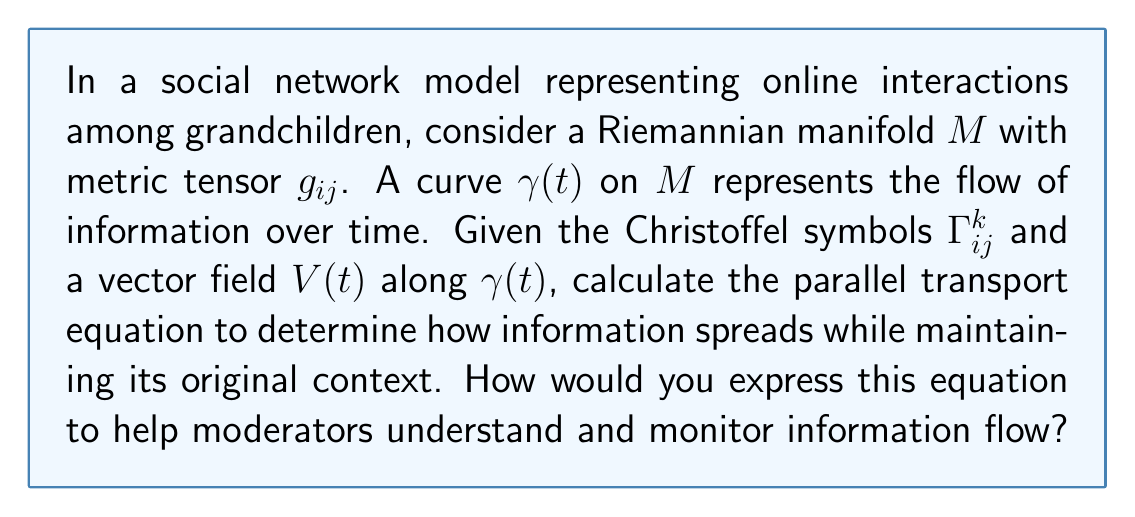What is the answer to this math problem? To understand how information spreads in a social network while maintaining its context, we can use parallel transport along a curve on a Riemannian manifold. This process helps moderators track and protect grandchildren from potential online risks. Let's break down the solution:

1. Recall the parallel transport equation:
   $$\frac{DV^i}{dt} = \frac{dV^i}{dt} + \Gamma^i_{jk} V^j \frac{d\gamma^k}{dt} = 0$$

2. Here, $V^i$ are the components of the vector field $V(t)$, representing the information being transported.

3. $\frac{d\gamma^k}{dt}$ represents the tangent vector to the curve $\gamma(t)$, indicating the direction of information flow.

4. $\Gamma^i_{jk}$ are the Christoffel symbols, which encode how the manifold (social network) is curved.

5. The equation states that the covariant derivative of $V$ along $\gamma$ is zero, meaning the vector is transported parallel to itself.

6. Expanding the equation:
   $$\frac{dV^i}{dt} = -\Gamma^i_{jk} V^j \frac{d\gamma^k}{dt}$$

7. This equation shows how the vector components change along the curve, helping moderators understand how information evolves as it spreads through the network.

8. To solve this, moderators would need to integrate the equation, given initial conditions and specific Christoffel symbols for their social network model.

By understanding this equation, moderators can better predict how information (including potential risks) propagates through the network, allowing them to implement more effective protection strategies for grandchildren.
Answer: $$\frac{dV^i}{dt} = -\Gamma^i_{jk} V^j \frac{d\gamma^k}{dt}$$ 